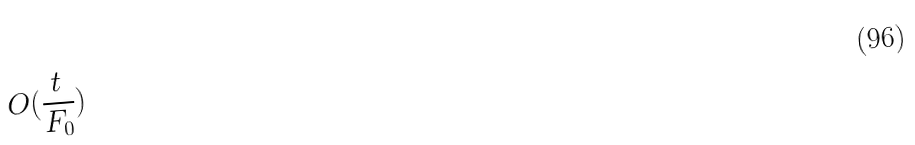Convert formula to latex. <formula><loc_0><loc_0><loc_500><loc_500>O ( \frac { t } { F _ { 0 } } )</formula> 